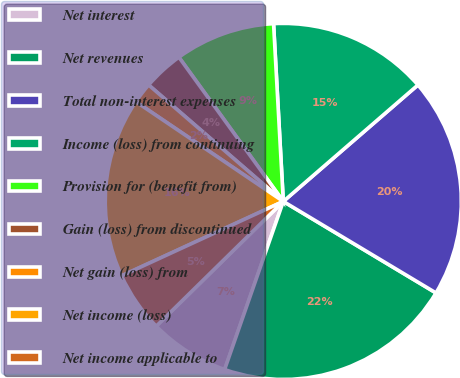<chart> <loc_0><loc_0><loc_500><loc_500><pie_chart><fcel>Net interest<fcel>Net revenues<fcel>Total non-interest expenses<fcel>Income (loss) from continuing<fcel>Provision for (benefit from)<fcel>Gain (loss) from discontinued<fcel>Net gain (loss) from<fcel>Net income (loss)<fcel>Net income applicable to<nl><fcel>7.3%<fcel>21.75%<fcel>19.94%<fcel>14.52%<fcel>9.1%<fcel>3.68%<fcel>1.88%<fcel>16.33%<fcel>5.49%<nl></chart> 